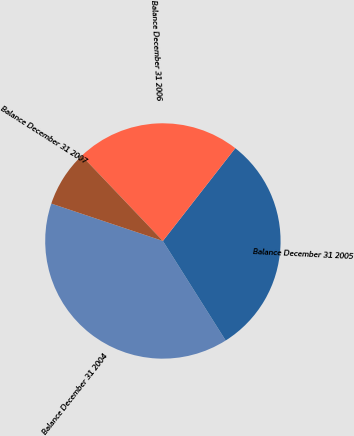Convert chart to OTSL. <chart><loc_0><loc_0><loc_500><loc_500><pie_chart><fcel>Balance December 31 2004<fcel>Balance December 31 2005<fcel>Balance December 31 2006<fcel>Balance December 31 2007<nl><fcel>39.11%<fcel>30.5%<fcel>22.66%<fcel>7.74%<nl></chart> 